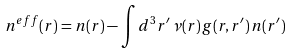Convert formula to latex. <formula><loc_0><loc_0><loc_500><loc_500>n ^ { e f f } ( r ) = n ( r ) - \int d ^ { 3 } r ^ { \prime } \, \nu ( r ) \, g ( r , r ^ { \prime } ) \, n ( r ^ { \prime } )</formula> 